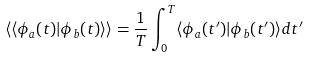Convert formula to latex. <formula><loc_0><loc_0><loc_500><loc_500>\langle \langle \phi _ { a } ( t ) | \phi _ { b } ( t ) \rangle \rangle = \frac { 1 } { T } \int _ { 0 } ^ { T } \langle \phi _ { a } ( t ^ { \prime } ) | \phi _ { b } ( t ^ { \prime } ) \rangle d t ^ { \prime }</formula> 